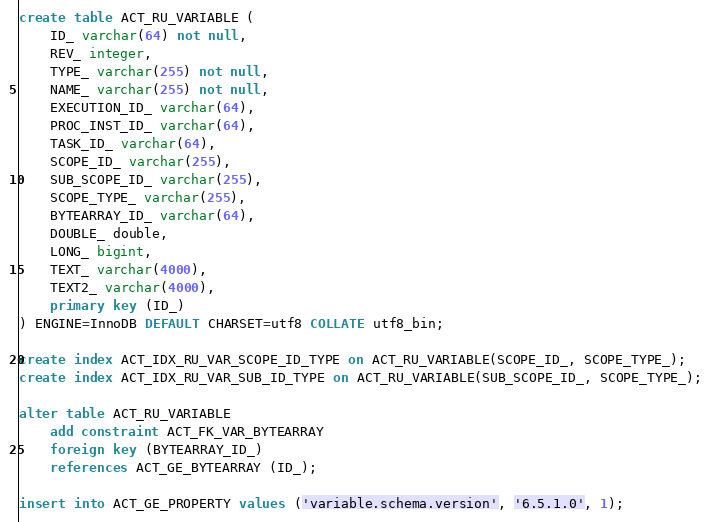<code> <loc_0><loc_0><loc_500><loc_500><_SQL_>create table ACT_RU_VARIABLE (
    ID_ varchar(64) not null,
    REV_ integer,
    TYPE_ varchar(255) not null,
    NAME_ varchar(255) not null,
    EXECUTION_ID_ varchar(64),
    PROC_INST_ID_ varchar(64),
    TASK_ID_ varchar(64),
    SCOPE_ID_ varchar(255),
    SUB_SCOPE_ID_ varchar(255),
    SCOPE_TYPE_ varchar(255),
    BYTEARRAY_ID_ varchar(64),
    DOUBLE_ double,
    LONG_ bigint,
    TEXT_ varchar(4000),
    TEXT2_ varchar(4000),
    primary key (ID_)
) ENGINE=InnoDB DEFAULT CHARSET=utf8 COLLATE utf8_bin;

create index ACT_IDX_RU_VAR_SCOPE_ID_TYPE on ACT_RU_VARIABLE(SCOPE_ID_, SCOPE_TYPE_);
create index ACT_IDX_RU_VAR_SUB_ID_TYPE on ACT_RU_VARIABLE(SUB_SCOPE_ID_, SCOPE_TYPE_);

alter table ACT_RU_VARIABLE 
    add constraint ACT_FK_VAR_BYTEARRAY 
    foreign key (BYTEARRAY_ID_) 
    references ACT_GE_BYTEARRAY (ID_);

insert into ACT_GE_PROPERTY values ('variable.schema.version', '6.5.1.0', 1);</code> 